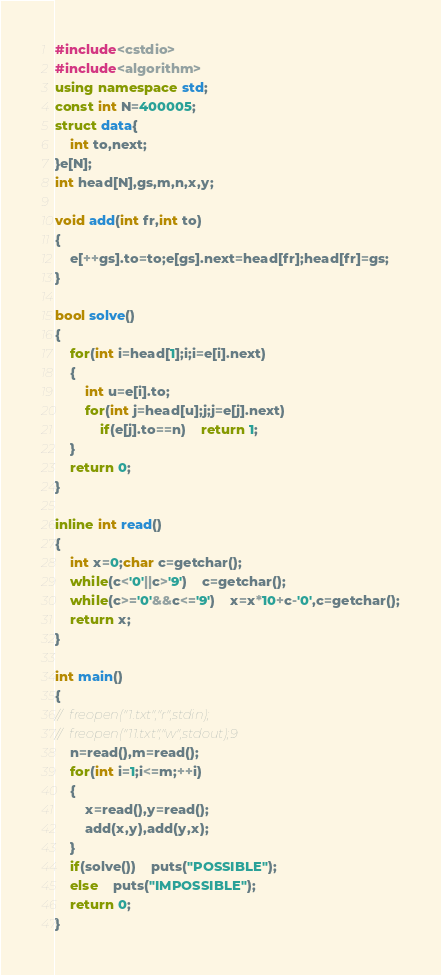Convert code to text. <code><loc_0><loc_0><loc_500><loc_500><_C++_>#include<cstdio>
#include<algorithm>
using namespace std;
const int N=400005;
struct data{
	int to,next;
}e[N];
int head[N],gs,m,n,x,y;

void add(int fr,int to)
{
	e[++gs].to=to;e[gs].next=head[fr];head[fr]=gs;
}

bool solve()
{
	for(int i=head[1];i;i=e[i].next)
	{
		int u=e[i].to;
		for(int j=head[u];j;j=e[j].next)
			if(e[j].to==n)	return 1;
	}
	return 0;
}

inline int read()
{
	int x=0;char c=getchar();
	while(c<'0'||c>'9')	c=getchar();
	while(c>='0'&&c<='9')	x=x*10+c-'0',c=getchar();
	return x;
}

int main()
{
//	freopen("1.txt","r",stdin);
//	freopen("11.txt","w",stdout);9
	n=read(),m=read();
	for(int i=1;i<=m;++i)
	{
		x=read(),y=read();
		add(x,y),add(y,x);
	}
	if(solve())	puts("POSSIBLE");
	else	puts("IMPOSSIBLE");
	return 0;
}</code> 